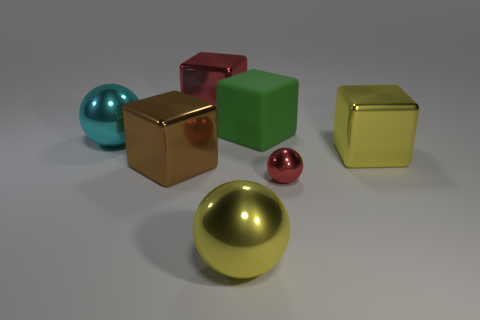There is a big object that is the same color as the tiny metallic object; what is it made of?
Make the answer very short. Metal. Are there any other metal objects that have the same shape as the small object?
Make the answer very short. Yes. What number of red things are small matte blocks or spheres?
Your response must be concise. 1. Is there a object that has the same size as the yellow shiny cube?
Your answer should be compact. Yes. How many large metallic blocks are there?
Offer a very short reply. 3. How many big things are either red metal balls or cyan rubber cylinders?
Ensure brevity in your answer.  0. What color is the block right of the red thing right of the big ball that is right of the red cube?
Keep it short and to the point. Yellow. How many other things are there of the same color as the small ball?
Offer a terse response. 1. What number of matte things are either large green blocks or large yellow balls?
Provide a short and direct response. 1. Is the color of the large ball that is right of the big red block the same as the big metal block to the right of the small metal ball?
Offer a terse response. Yes. 